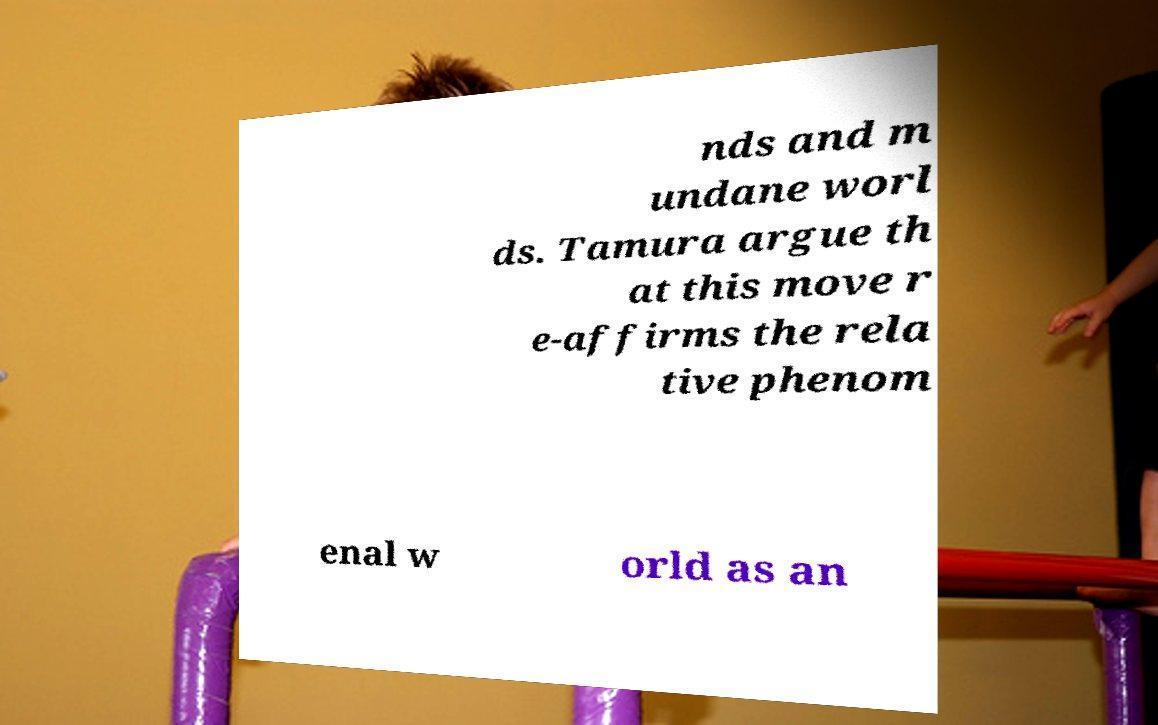Please identify and transcribe the text found in this image. nds and m undane worl ds. Tamura argue th at this move r e-affirms the rela tive phenom enal w orld as an 